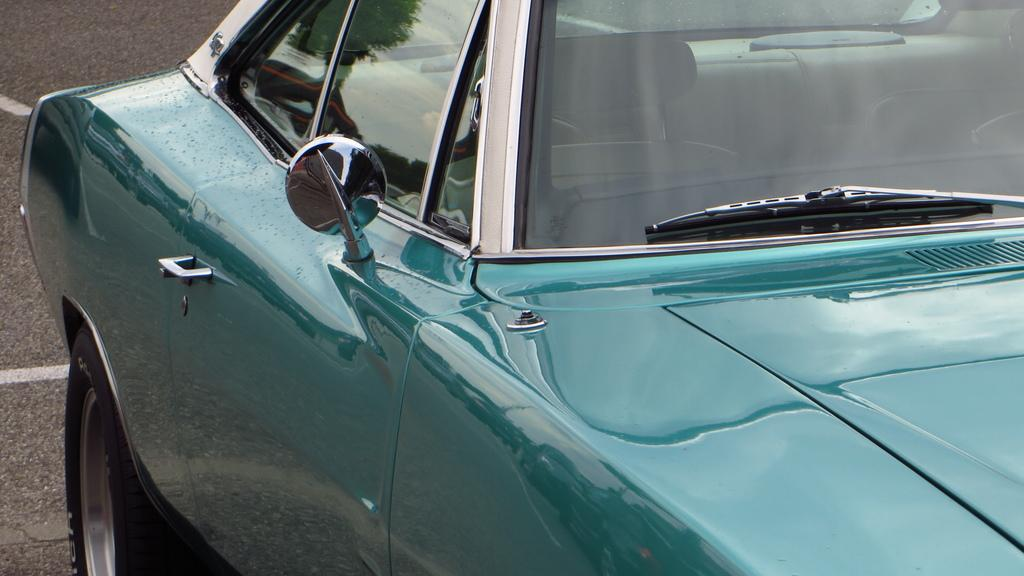What is the main subject of the image? There is a vehicle in the image. What can be seen in the background of the image? There is a road visible in the background of the image. What type of veil is draped over the vehicle in the image? There is no veil present in the image; it is a vehicle on a road. What songs can be heard playing from the vehicle in the image? There is no information about any songs playing in the image; it only shows a vehicle on a road. 